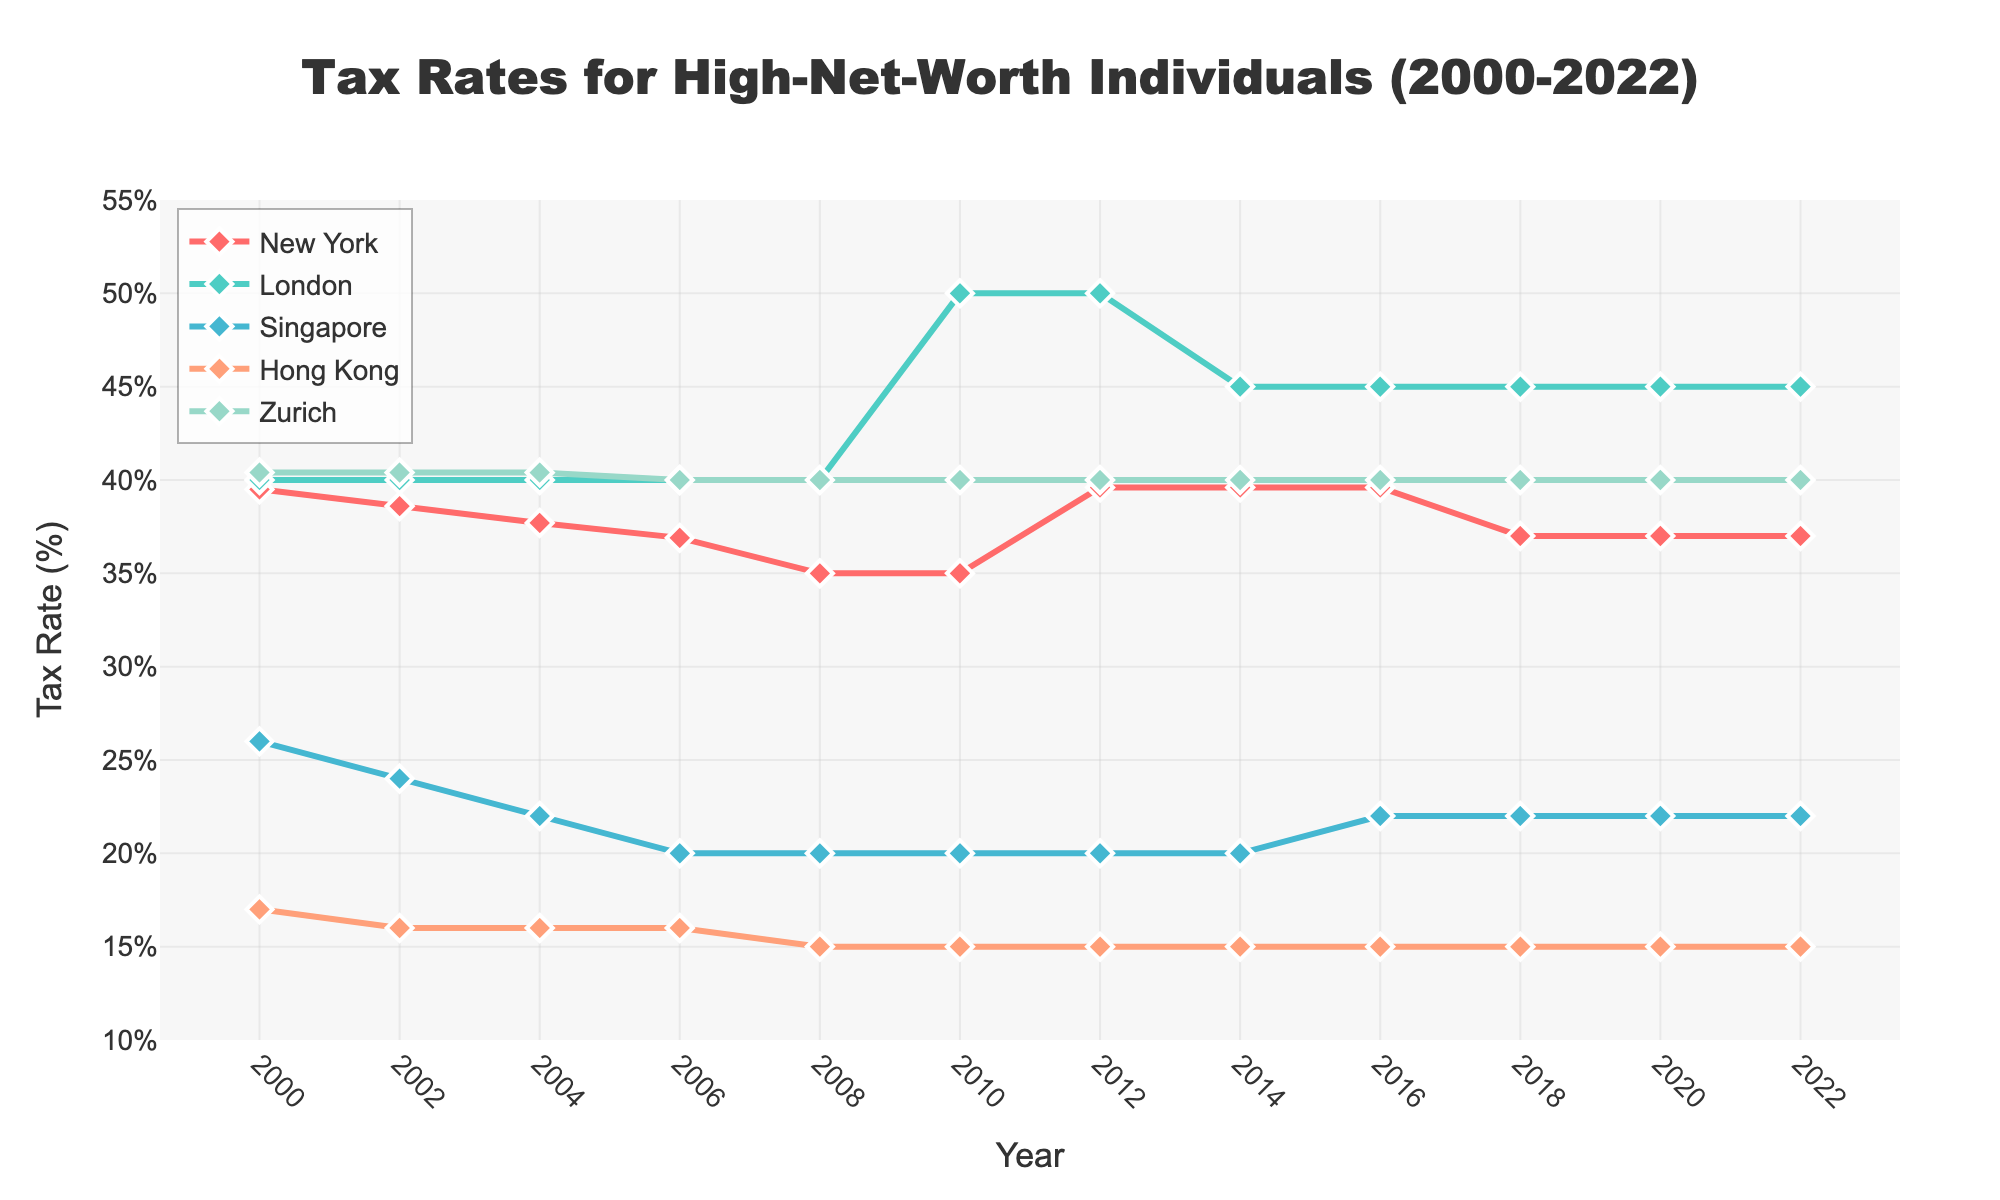What is the trend of the tax rate in New York from 2000 to 2022? From the figure, observe the line representing New York (red line). Starting at around 39.5% in 2000, the tax rate decreases gradually, hitting a low of 35% in 2008 and 2010. It then spikes to 39.6% in 2012, then stabilizes around 37.0% from 2018 to 2022.
Answer: Generally decreasing, with a spike in 2012, stabilizing at 37% Which city had the highest tax rate in 2012? Analyze the lines at the year 2012. London (green line) reaches the highest point at 50%, compared to others.
Answer: London What is the average tax rate of Hong Kong between 2000 and 2022? Identify the values for Hong Kong from 2000 to 2022 (17.0, 16.0, 16.0, 16.0, 15.0, 15.0, 15.0, 15.0, 15.0, 15.0, 15.0, 15.0). Sum these values and divide by the count (12). Calculation: (17 + 16 + 16 + 16 + 15 + 15 + 15 + 15 + 15 + 15 + 15 + 15) / 12 = 15.333.
Answer: 15.33% Between Zurich and Singapore, which city had a lower tax rate in 2004? Compare the values for Zurich (blue line, around 40.4%) and Singapore (yellow line, around 22%) in 2004.
Answer: Singapore What is the difference in tax rates in London between 2008 and 2010? Subtract the value in 2008 (40.0%) from the value in 2010 (50.0%). Difference = 50.0% - 40.0% = 10%.
Answer: 10% Which city maintains a constant tax rate from 2008 to 2022 and what is the value? Observing the lines, Hong Kong (purple) and Zurich (light blue) have stable tax rates. Specifically, Hong Kong's line is flat at 15.0% during this period.
Answer: Hong Kong, 15.0% Was there any year when New York and Zurich had the same tax rate? Compare the New York (red line) and Zurich (light blue line) points at each year. Both have similar values around the early 2000s. In 2006, both appear to have the tax rate around 36.9-40%.
Answer: 2006 If I want to move to a place with the lowest recent tax rate, where should I go based on 2022 data? On the line chart at 2022, find the city with the lowest point. Hong Kong (purple line) is at 15.0%.
Answer: Hong Kong How did the tax rate in Singapore change from 2000 to 2006? The tax rate in Singapore (yellow line) starts at 26.0% in 2000, then decreases to 20.0% in 2006, via intermediate values (24 in 2002, 22 in 2004). Decrease = 26.0% - 20.0% = 6%.
Answer: Decreased by 6% In which year did London experience the most significant tax rate increase, and what was the rate difference? Look for the largest vertical jump in London's (green) line. From 2008 to 2010, the tax rate jumps from 40.0% to 50.0%, a difference of 10%.
Answer: 2010, 10% 